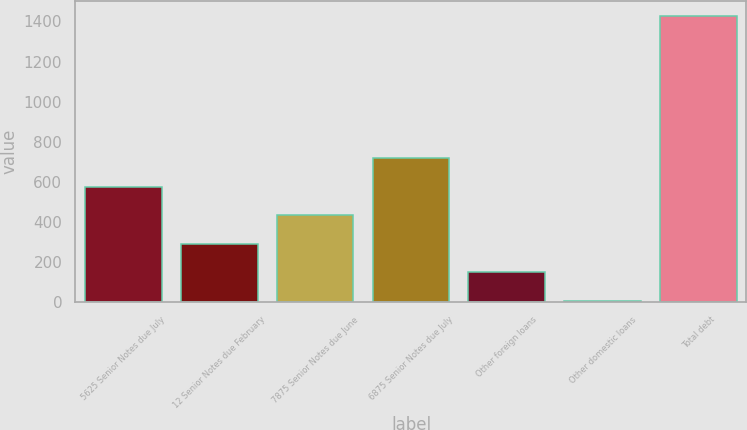<chart> <loc_0><loc_0><loc_500><loc_500><bar_chart><fcel>5625 Senior Notes due July<fcel>12 Senior Notes due February<fcel>7875 Senior Notes due June<fcel>6875 Senior Notes due July<fcel>Other foreign loans<fcel>Other domestic loans<fcel>Total debt<nl><fcel>575.58<fcel>291.04<fcel>433.31<fcel>717.85<fcel>148.77<fcel>6.5<fcel>1429.2<nl></chart> 